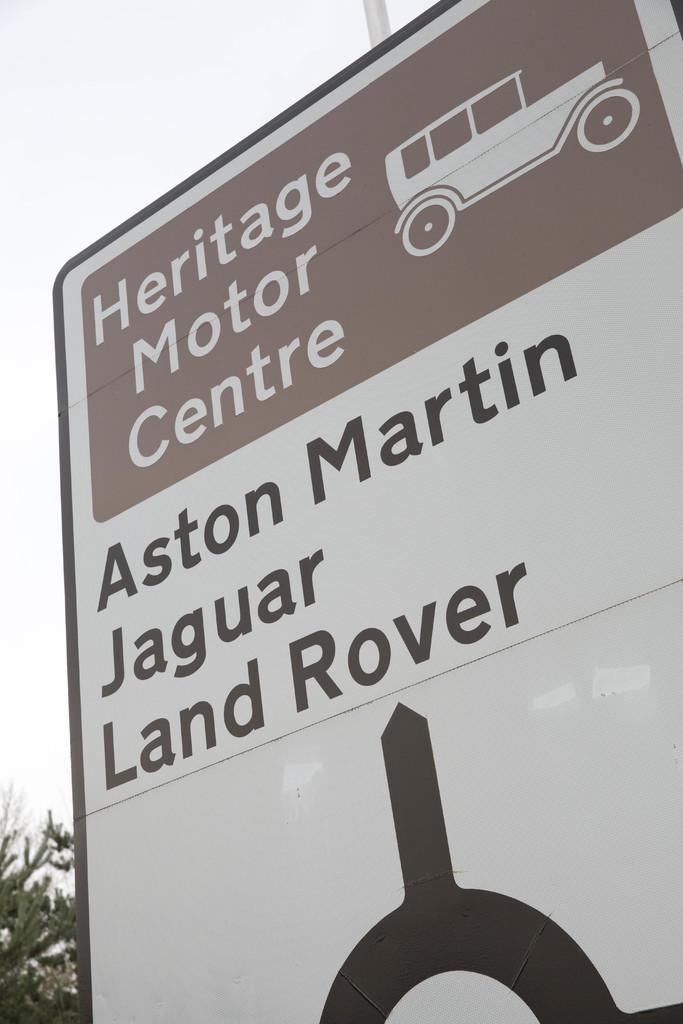What is the main object in the image? There is a banner in the image. What can be seen on the banner? There is writing and a drawing on the banner. What does the writing on the banner say? The writing says "Heritage Motor Center". What is depicted in the drawing on the banner? There is a drawing of a car on the banner. How many friends are sitting on the quince in the image? There is no quince or friends present in the image; it features a banner with writing and a drawing of a car. 